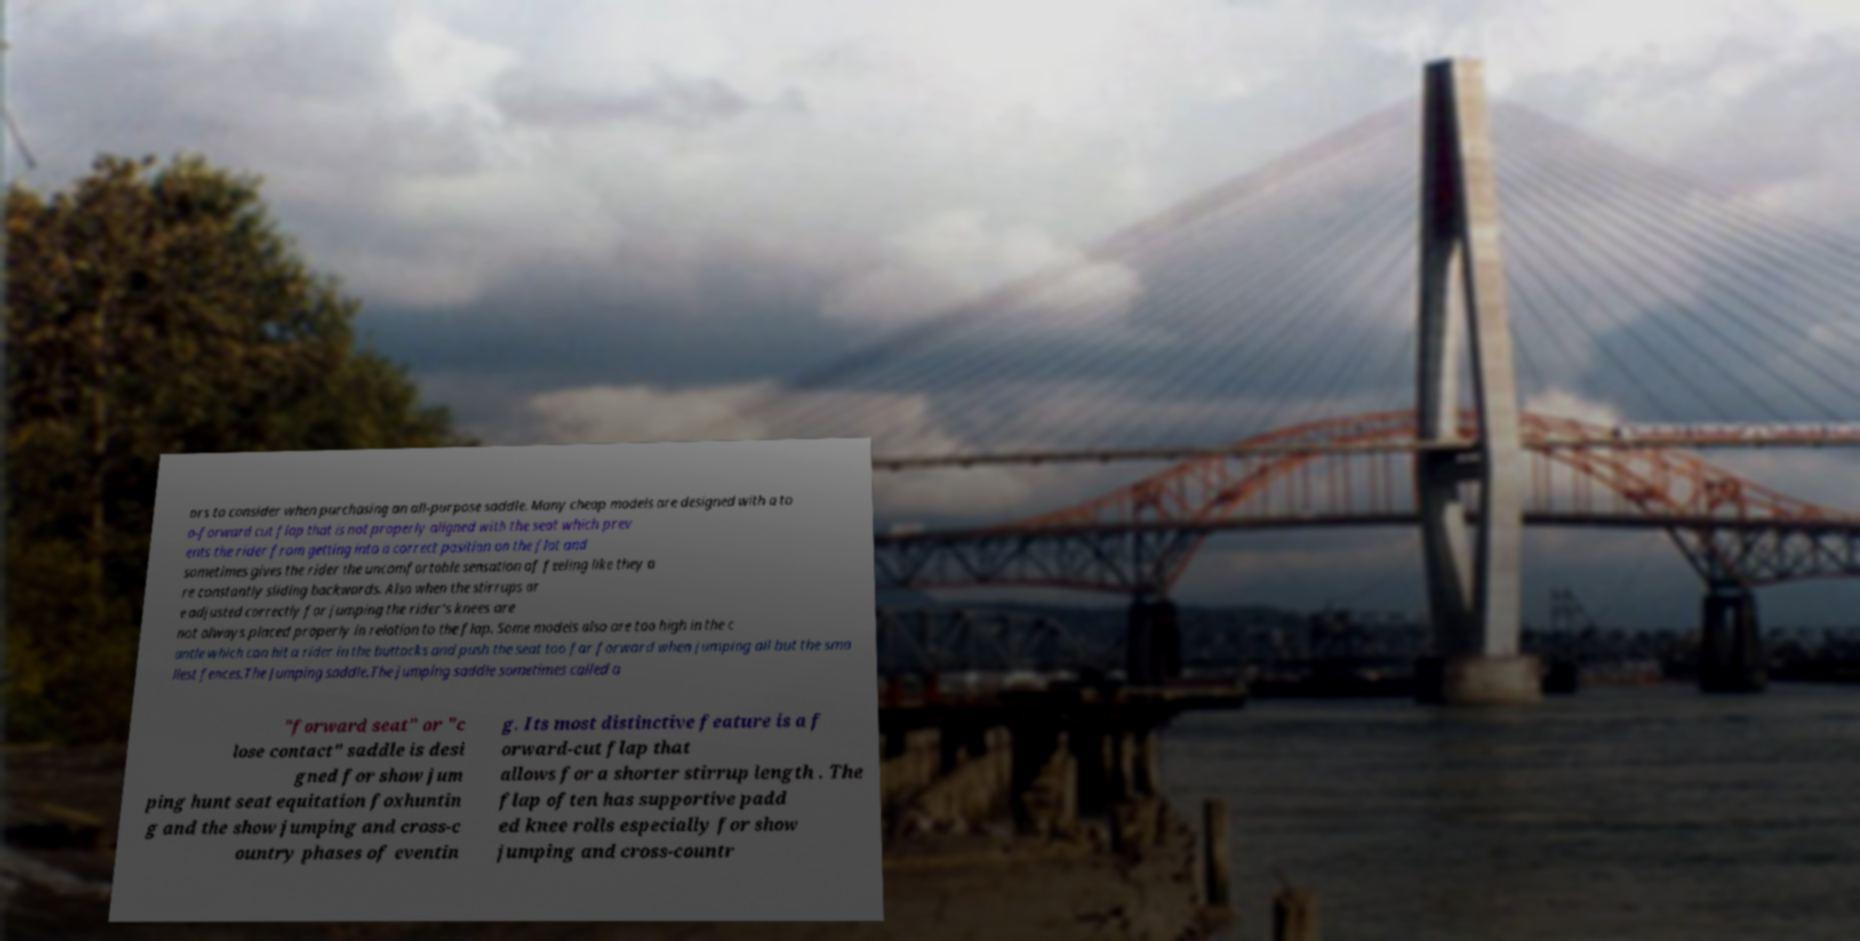There's text embedded in this image that I need extracted. Can you transcribe it verbatim? ors to consider when purchasing an all-purpose saddle. Many cheap models are designed with a to o-forward cut flap that is not properly aligned with the seat which prev ents the rider from getting into a correct position on the flat and sometimes gives the rider the uncomfortable sensation of feeling like they a re constantly sliding backwards. Also when the stirrups ar e adjusted correctly for jumping the rider's knees are not always placed properly in relation to the flap. Some models also are too high in the c antle which can hit a rider in the buttocks and push the seat too far forward when jumping all but the sma llest fences.The Jumping saddle.The jumping saddle sometimes called a "forward seat" or "c lose contact" saddle is desi gned for show jum ping hunt seat equitation foxhuntin g and the show jumping and cross-c ountry phases of eventin g. Its most distinctive feature is a f orward-cut flap that allows for a shorter stirrup length . The flap often has supportive padd ed knee rolls especially for show jumping and cross-countr 